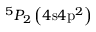Convert formula to latex. <formula><loc_0><loc_0><loc_500><loc_500>^ { 5 } P _ { 2 } \left ( 4 s 4 p ^ { 2 } \right )</formula> 